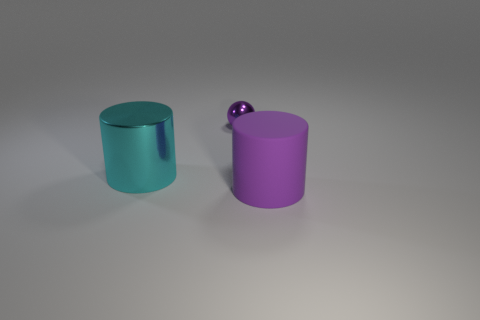There is a large cylinder that is left of the purple object that is behind the big cyan metallic cylinder; what is its color?
Offer a terse response. Cyan. What is the color of the metallic object that is the same size as the purple rubber cylinder?
Your answer should be compact. Cyan. How many purple things are behind the large rubber thing and in front of the purple metallic sphere?
Make the answer very short. 0. What is the shape of the large matte thing that is the same color as the tiny sphere?
Provide a succinct answer. Cylinder. What is the object that is behind the large purple cylinder and in front of the tiny metal thing made of?
Make the answer very short. Metal. Is the number of cyan metal cylinders that are in front of the large cyan thing less than the number of big cyan cylinders that are to the left of the purple shiny thing?
Make the answer very short. Yes. The purple thing that is made of the same material as the cyan cylinder is what size?
Offer a very short reply. Small. Is there any other thing of the same color as the tiny thing?
Keep it short and to the point. Yes. Does the big cyan object have the same material as the purple thing that is to the left of the large purple rubber object?
Offer a terse response. Yes. What material is the other large purple object that is the same shape as the large metallic object?
Give a very brief answer. Rubber. 